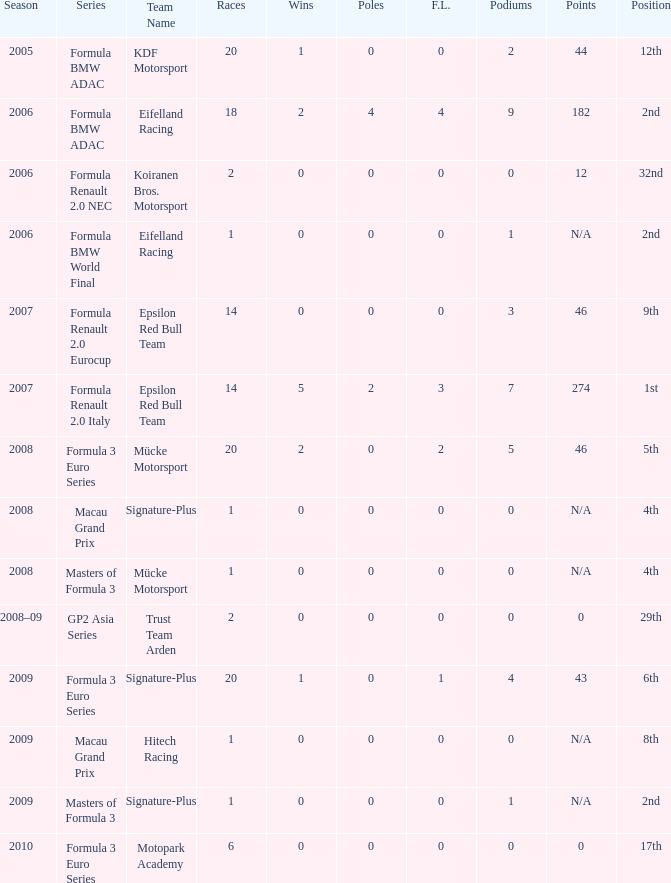In the 32nd position, how many podiums are usually attained by those with fewer than 0 wins? None. 